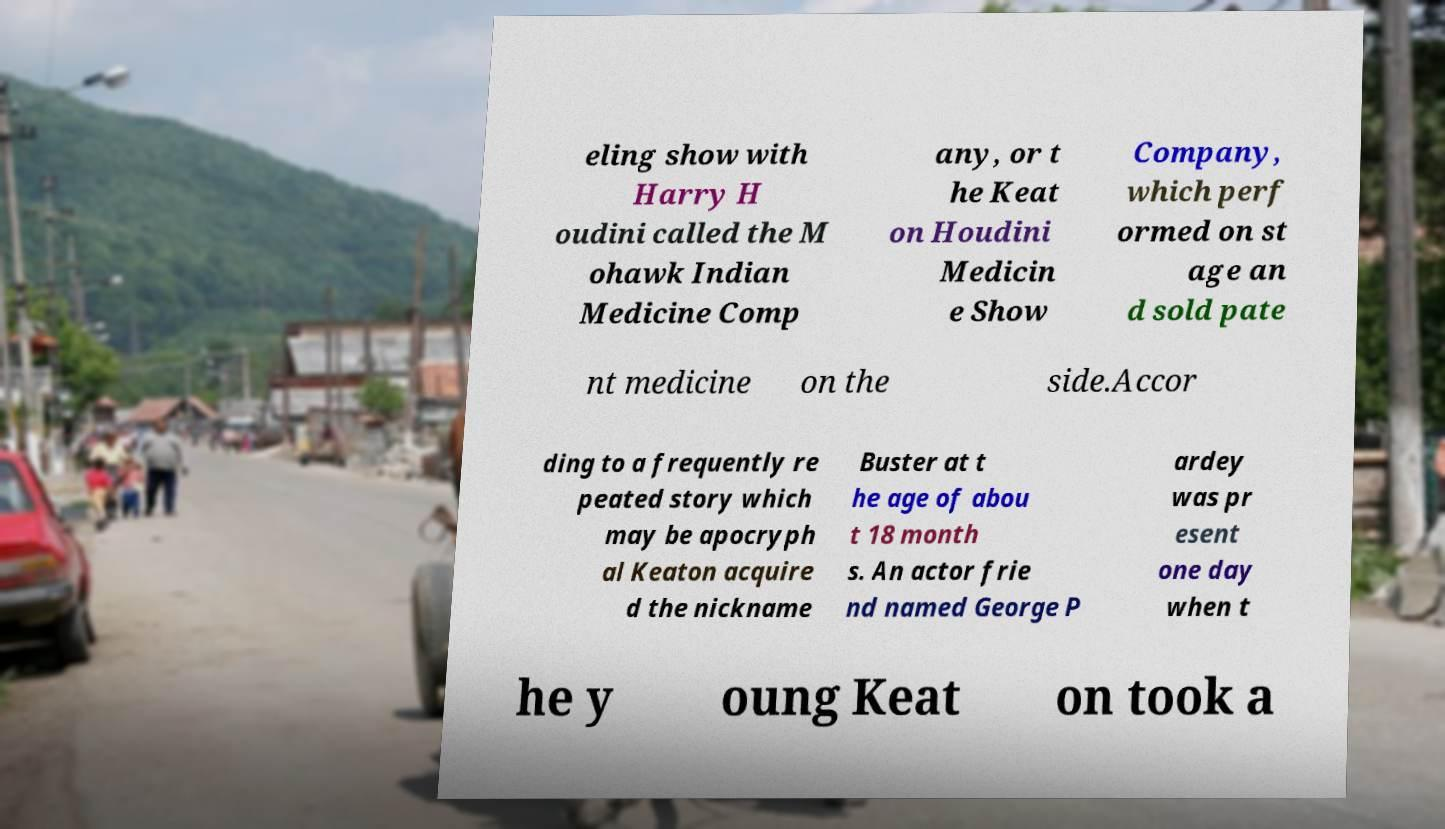Please read and relay the text visible in this image. What does it say? eling show with Harry H oudini called the M ohawk Indian Medicine Comp any, or t he Keat on Houdini Medicin e Show Company, which perf ormed on st age an d sold pate nt medicine on the side.Accor ding to a frequently re peated story which may be apocryph al Keaton acquire d the nickname Buster at t he age of abou t 18 month s. An actor frie nd named George P ardey was pr esent one day when t he y oung Keat on took a 